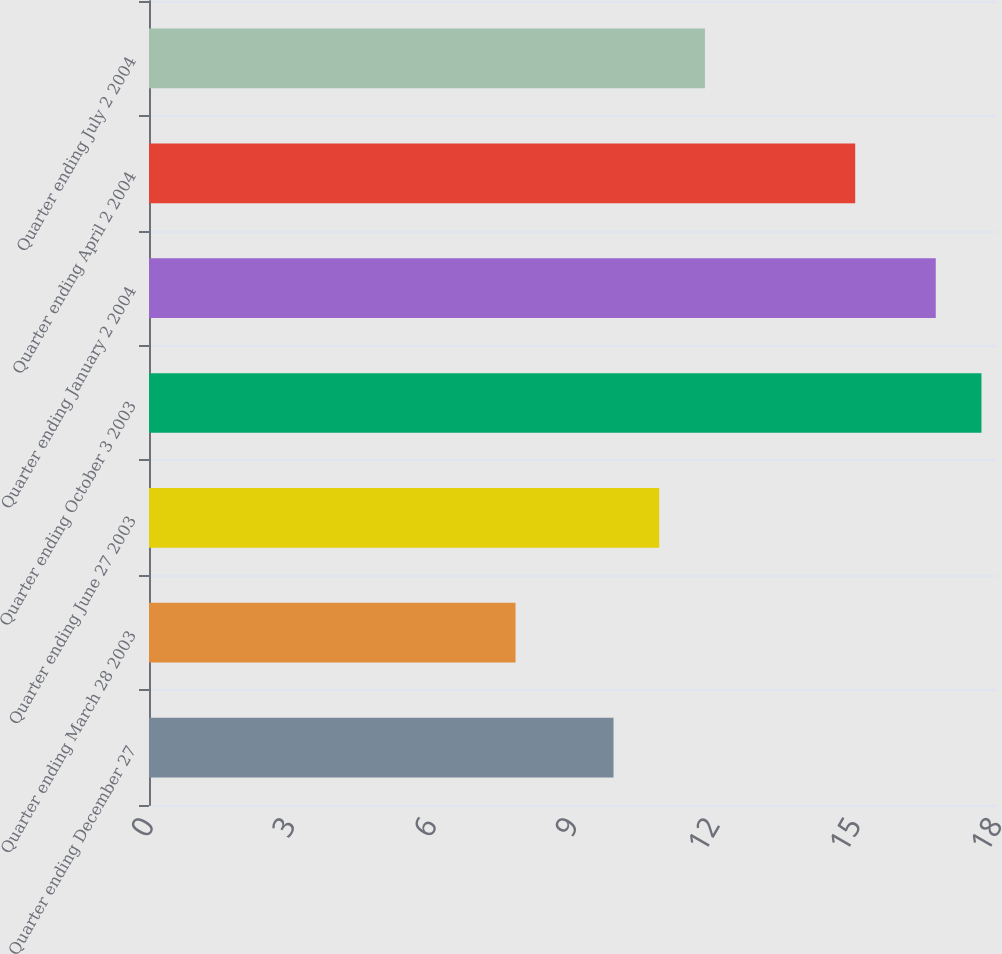<chart> <loc_0><loc_0><loc_500><loc_500><bar_chart><fcel>Quarter ending December 27<fcel>Quarter ending March 28 2003<fcel>Quarter ending June 27 2003<fcel>Quarter ending October 3 2003<fcel>Quarter ending January 2 2004<fcel>Quarter ending April 2 2004<fcel>Quarter ending July 2 2004<nl><fcel>9.86<fcel>7.78<fcel>10.83<fcel>17.67<fcel>16.7<fcel>14.99<fcel>11.8<nl></chart> 